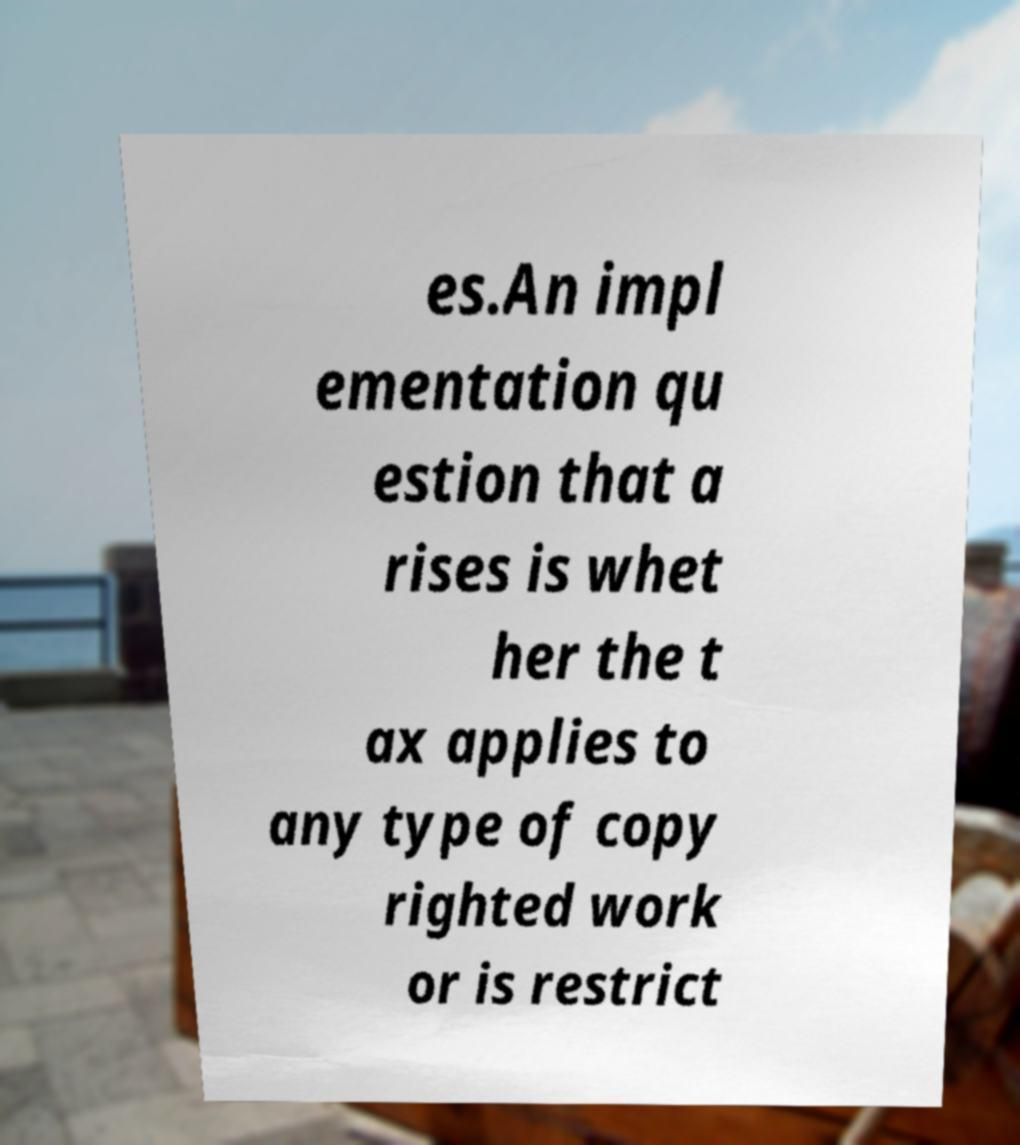Can you read and provide the text displayed in the image?This photo seems to have some interesting text. Can you extract and type it out for me? es.An impl ementation qu estion that a rises is whet her the t ax applies to any type of copy righted work or is restrict 